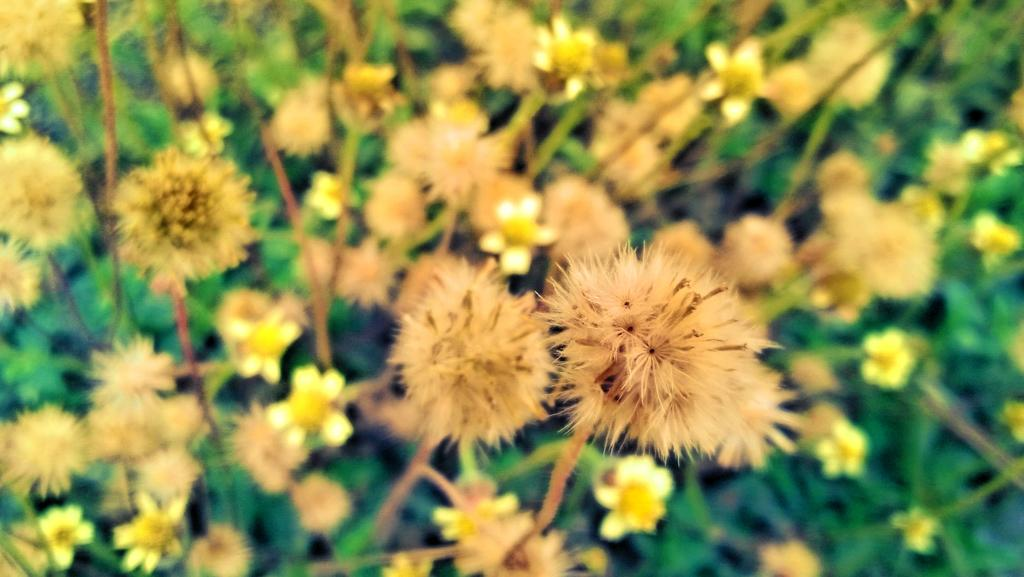What type of plants can be seen in the image? There are flower plants in the image. What part of the flower plants is visible in the image? The flower plants have leaves. What type of crown is the flower plant wearing in the image? There is no crown present in the image; it features flower plants with leaves. How many chairs are visible in the image? There are no chairs present in the image. 